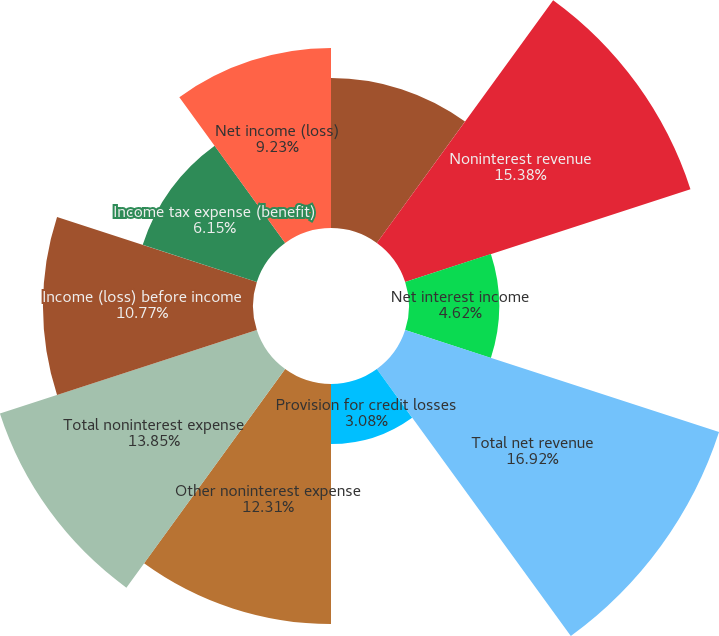Convert chart. <chart><loc_0><loc_0><loc_500><loc_500><pie_chart><fcel>(in millions except ratios)<fcel>Noninterest revenue<fcel>Net interest income<fcel>Total net revenue<fcel>Provision for credit losses<fcel>Other noninterest expense<fcel>Total noninterest expense<fcel>Income (loss) before income<fcel>Income tax expense (benefit)<fcel>Net income (loss)<nl><fcel>7.69%<fcel>15.38%<fcel>4.62%<fcel>16.92%<fcel>3.08%<fcel>12.31%<fcel>13.85%<fcel>10.77%<fcel>6.15%<fcel>9.23%<nl></chart> 